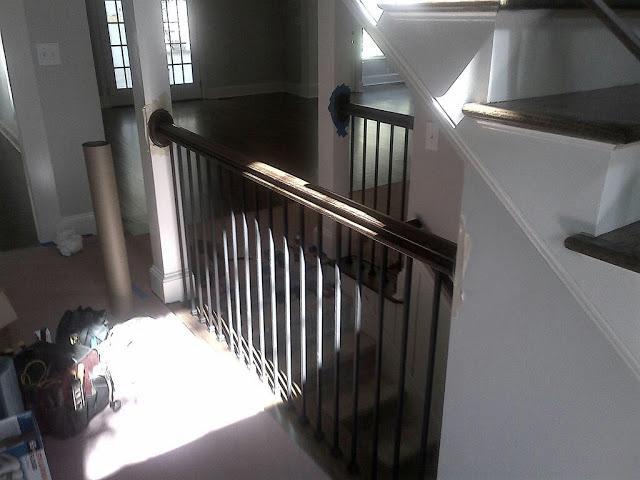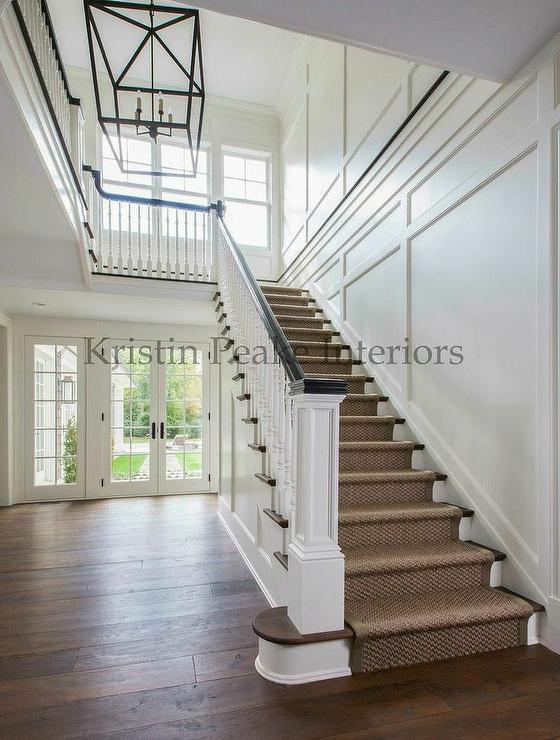The first image is the image on the left, the second image is the image on the right. Evaluate the accuracy of this statement regarding the images: "The right image shows a staircase enclosed by white baseboard, with a dark handrail and white spindles, and the staircase ascends to a landing before turning directions.". Is it true? Answer yes or no. Yes. The first image is the image on the left, the second image is the image on the right. Evaluate the accuracy of this statement regarding the images: "In at least one image there is a brown wooden floor at the bottom of the staircase.". Is it true? Answer yes or no. Yes. 